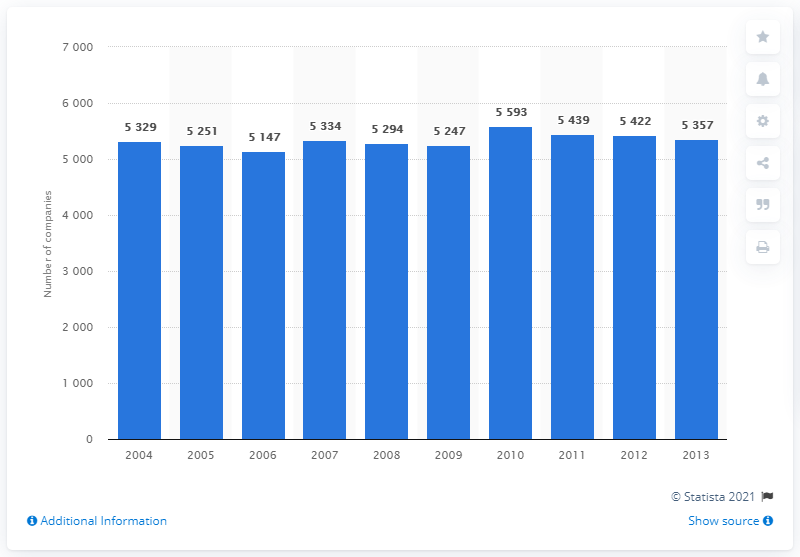In which year did the insurance sector experience the greatest decrease in the number of companies? Between 2009 and 2010, the insurance sector experienced the most significant decrease in active companies, dropping from 5,593 to 5,439. 